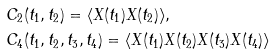<formula> <loc_0><loc_0><loc_500><loc_500>& C _ { 2 } ( t _ { 1 } , t _ { 2 } ) = \langle X ( t _ { 1 } ) X ( t _ { 2 } ) \rangle , \\ & C _ { 4 } ( t _ { 1 } , t _ { 2 } , t _ { 3 } , t _ { 4 } ) = \langle X ( t _ { 1 } ) X ( t _ { 2 } ) X ( t _ { 3 } ) X ( t _ { 4 } ) \rangle</formula> 